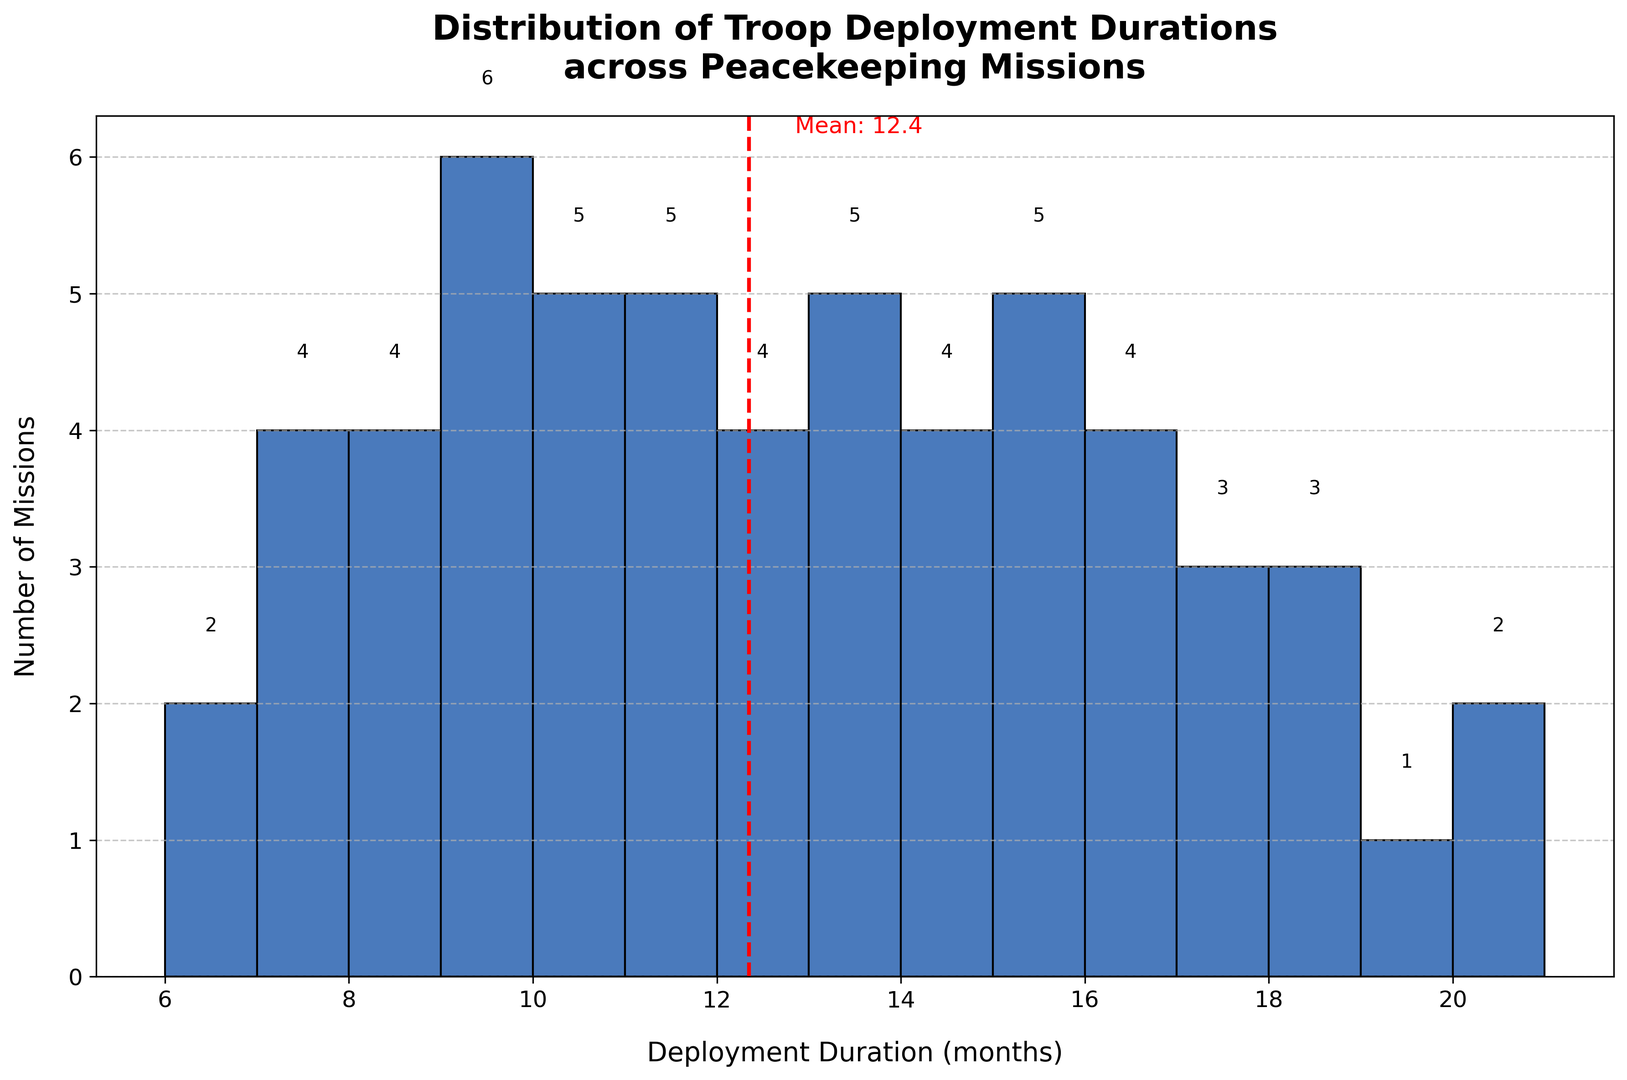What is the most common deployment duration range? By observing the histogram, identify the deployment duration range with the highest bar. This bar represents the most common range.
Answer: 9-10 months How many missions have a deployment duration of 12 months? Look for the bar corresponding to the 12-month duration and read its height or the number annotated above it.
Answer: 3 missions What is the mean deployment duration across the missions? Locate the red dashed line, which indicates the mean deployment duration. The exact mean value should also be annotated near the line.
Answer: 12.2 months Which deployment duration is closest to the mean? Determine the mean value and look for the bar nearest to this value on the histogram.
Answer: 12 months Are there more missions with deployment durations less than the mean or more than the mean? Count the number of bars to the left of the red dashed mean line and compare them with the number of bars to the right of the line.
Answer: More than the mean What is the range of deployment durations represented in the histogram? Identify the lowest and highest bin edges on the x-axis. These represent the range of deployment durations.
Answer: 6-21 months How many missions have deployment durations of 15 months or longer? Sum up the heights or annotations of all bars representing durations of 15 months or more.
Answer: 13 missions Which bin has the least number of missions, and what is that number? Look for the bar with the smallest height and note the corresponding deployment duration range and number of missions.
Answer: 6 months (2 missions) Compare the number of missions with deployment durations of 8 and 9 months. Which is greater? Compare the heights or annotations of the bars for 8 months and 9 months to determine which has more missions.
Answer: 9 months Are there any deployment durations that appear in the histogram but have no missions? Check if there are gaps (zero-height bars) in the histogram between any two bins.
Answer: No gaps 